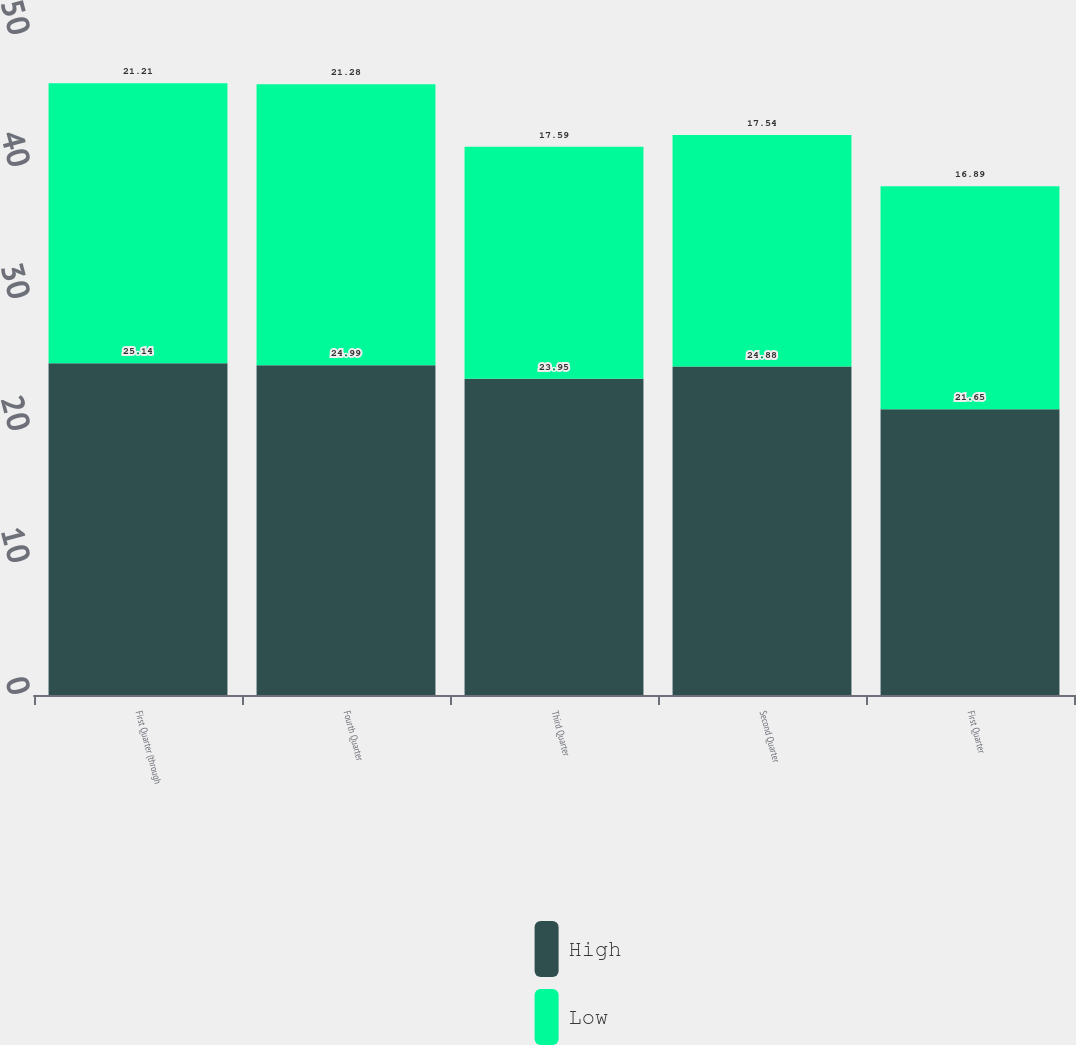Convert chart. <chart><loc_0><loc_0><loc_500><loc_500><stacked_bar_chart><ecel><fcel>First Quarter (through<fcel>Fourth Quarter<fcel>Third Quarter<fcel>Second Quarter<fcel>First Quarter<nl><fcel>High<fcel>25.14<fcel>24.99<fcel>23.95<fcel>24.88<fcel>21.65<nl><fcel>Low<fcel>21.21<fcel>21.28<fcel>17.59<fcel>17.54<fcel>16.89<nl></chart> 